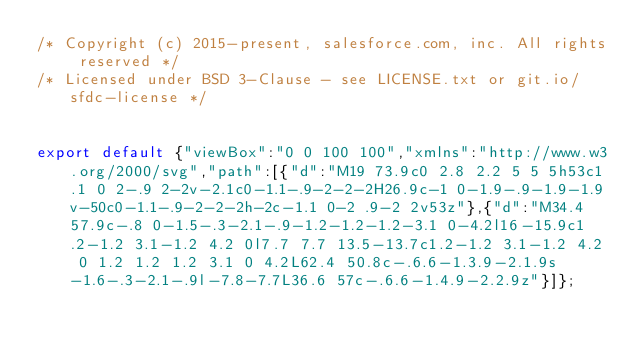Convert code to text. <code><loc_0><loc_0><loc_500><loc_500><_JavaScript_>/* Copyright (c) 2015-present, salesforce.com, inc. All rights reserved */
/* Licensed under BSD 3-Clause - see LICENSE.txt or git.io/sfdc-license */


export default {"viewBox":"0 0 100 100","xmlns":"http://www.w3.org/2000/svg","path":[{"d":"M19 73.9c0 2.8 2.2 5 5 5h53c1.1 0 2-.9 2-2v-2.1c0-1.1-.9-2-2-2H26.9c-1 0-1.9-.9-1.9-1.9v-50c0-1.1-.9-2-2-2h-2c-1.1 0-2 .9-2 2v53z"},{"d":"M34.4 57.9c-.8 0-1.5-.3-2.1-.9-1.2-1.2-1.2-3.1 0-4.2l16-15.9c1.2-1.2 3.1-1.2 4.2 0l7.7 7.7 13.5-13.7c1.2-1.2 3.1-1.2 4.2 0 1.2 1.2 1.2 3.1 0 4.2L62.4 50.8c-.6.6-1.3.9-2.1.9s-1.6-.3-2.1-.9l-7.8-7.7L36.6 57c-.6.6-1.4.9-2.2.9z"}]};
</code> 